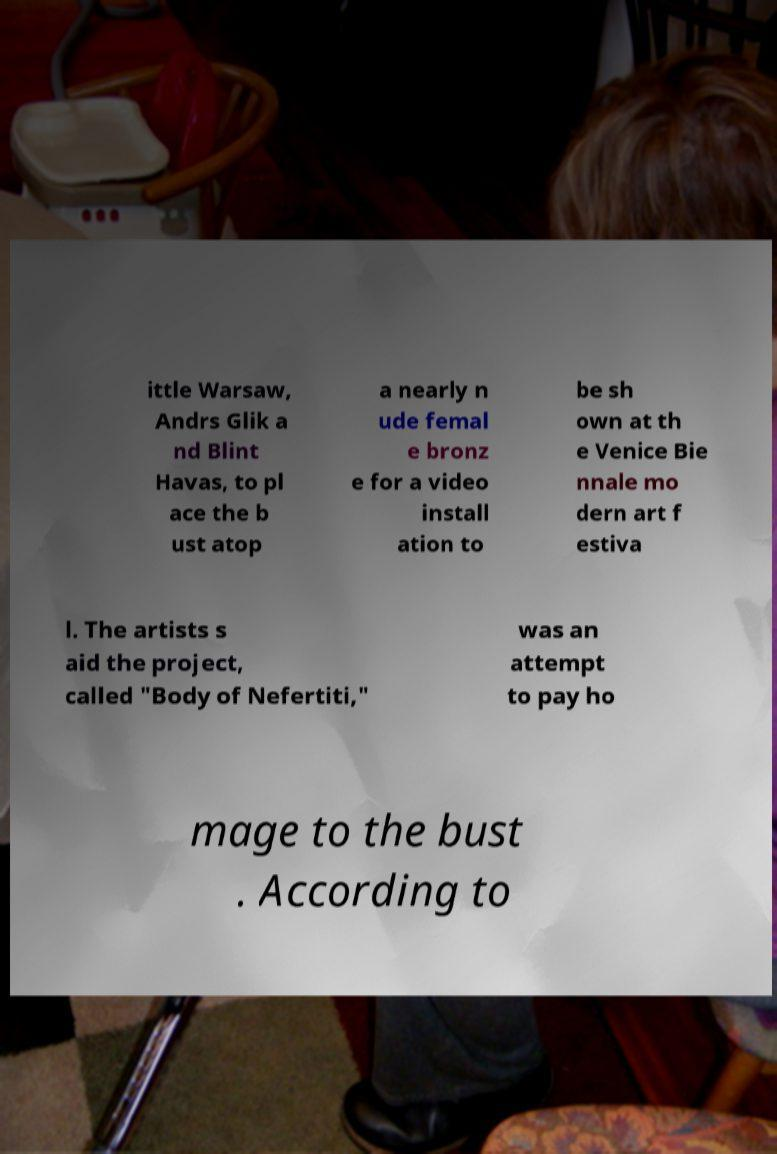What messages or text are displayed in this image? I need them in a readable, typed format. ittle Warsaw, Andrs Glik a nd Blint Havas, to pl ace the b ust atop a nearly n ude femal e bronz e for a video install ation to be sh own at th e Venice Bie nnale mo dern art f estiva l. The artists s aid the project, called "Body of Nefertiti," was an attempt to pay ho mage to the bust . According to 